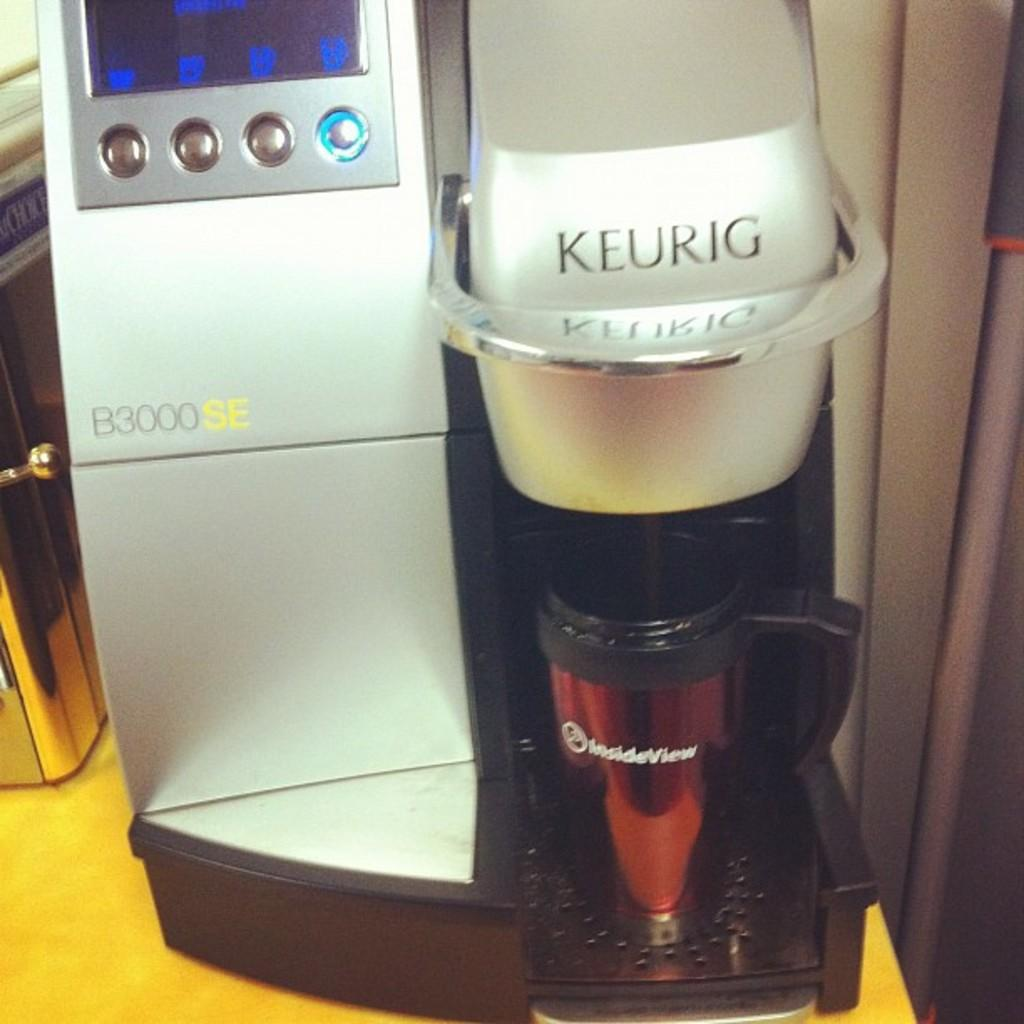<image>
Relay a brief, clear account of the picture shown. a keurig coffee machine that has the numbers 'b3000se' on it 